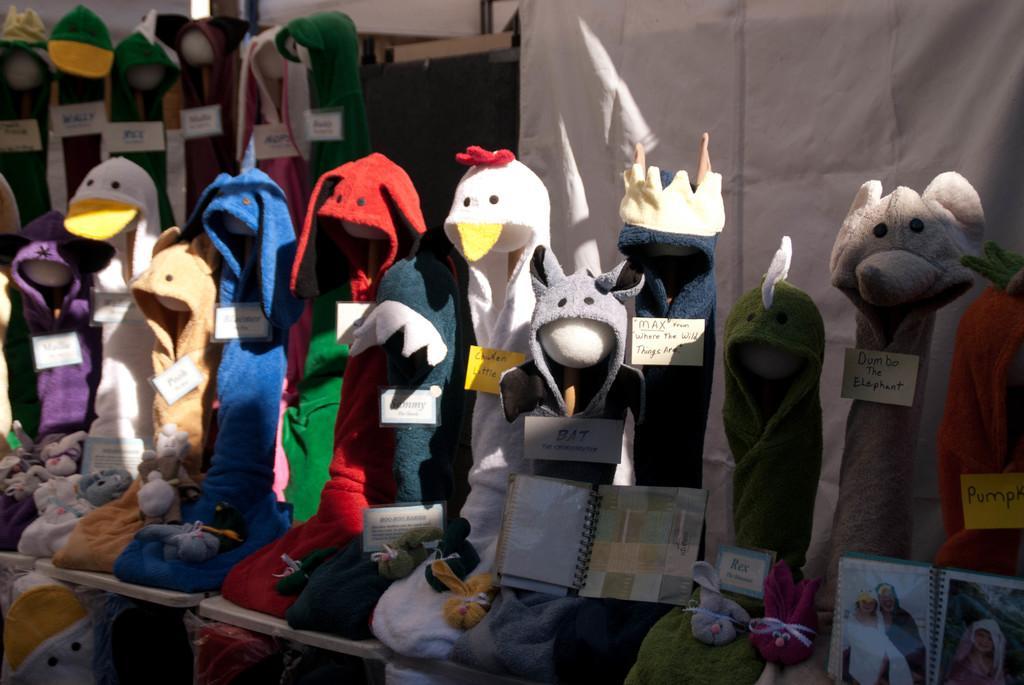In one or two sentences, can you explain what this image depicts? To the bottom of the image there are many toys with different masks and also there are name tags to it. To the right bottom corner of the image there is an album with photos in it. Behind them to the right top corner there is a white cloth. And also to the left top corner of the image there are few toys with masks and name tags to it. 